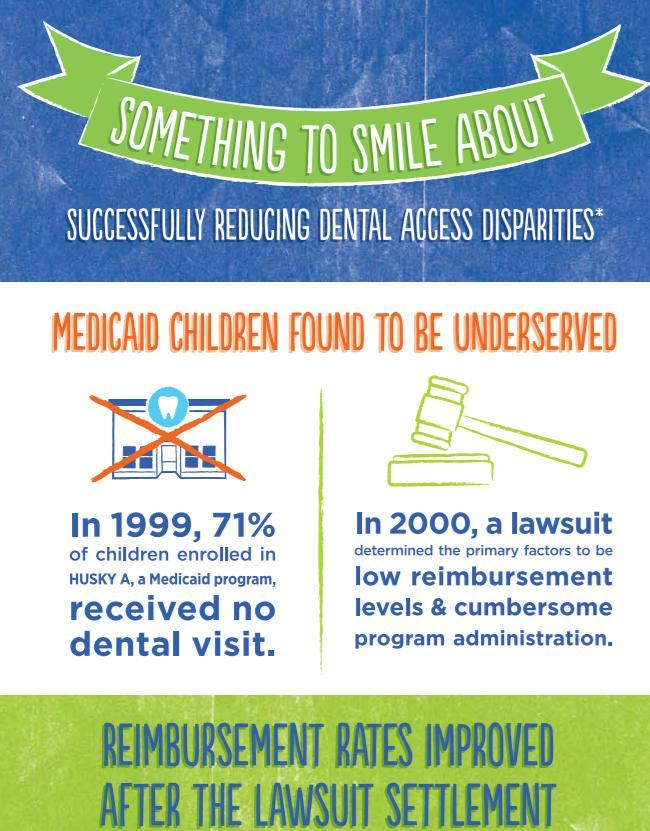What percentage of children received dental visits?
Answer the question with a short phrase. 29% 